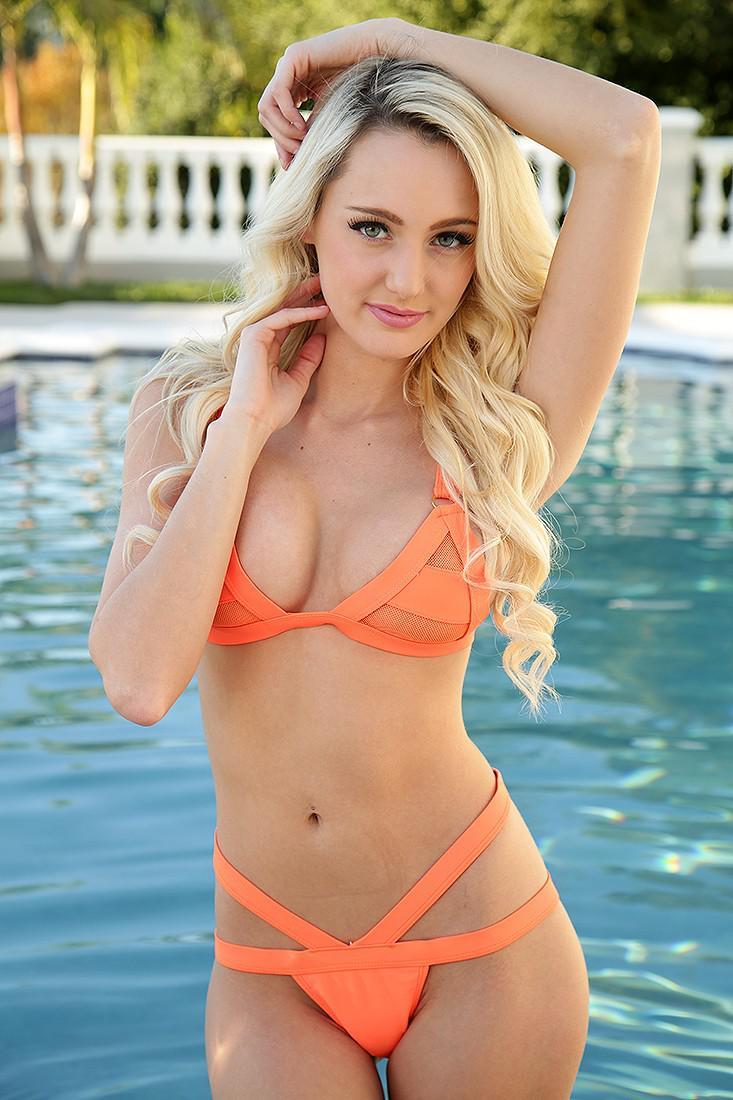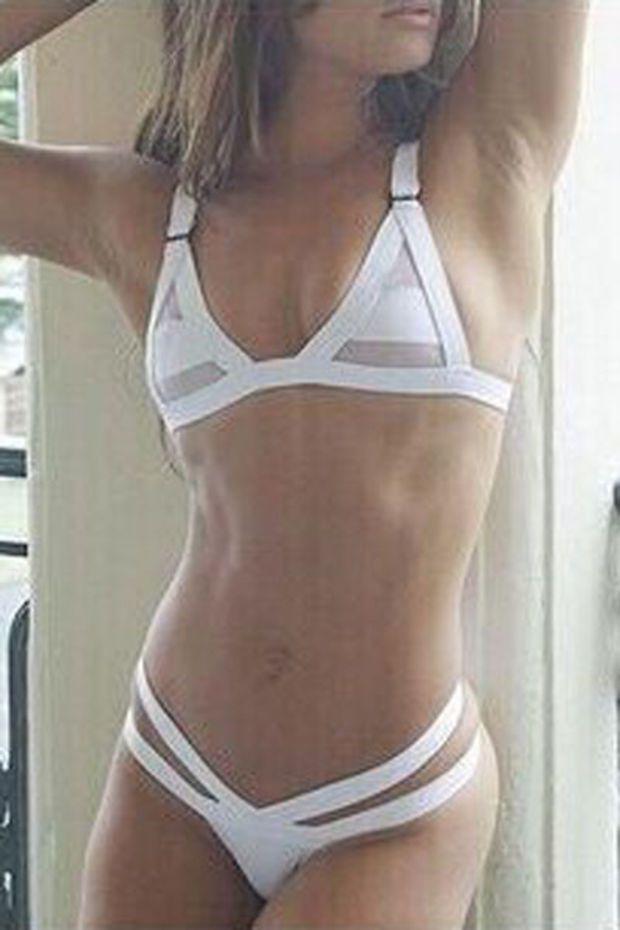The first image is the image on the left, the second image is the image on the right. Given the left and right images, does the statement "Models wear the same color bikinis in left and right images." hold true? Answer yes or no. No. The first image is the image on the left, the second image is the image on the right. Assess this claim about the two images: "In one of the images, a woman is wearing a white bikini". Correct or not? Answer yes or no. Yes. 